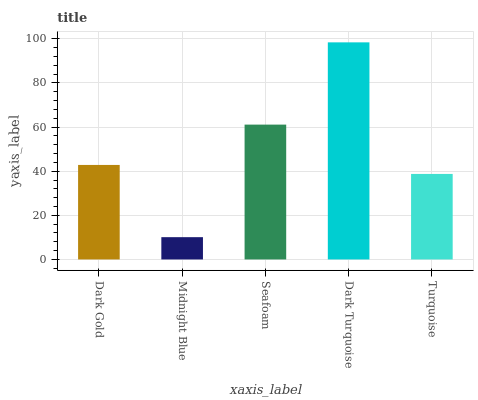Is Midnight Blue the minimum?
Answer yes or no. Yes. Is Dark Turquoise the maximum?
Answer yes or no. Yes. Is Seafoam the minimum?
Answer yes or no. No. Is Seafoam the maximum?
Answer yes or no. No. Is Seafoam greater than Midnight Blue?
Answer yes or no. Yes. Is Midnight Blue less than Seafoam?
Answer yes or no. Yes. Is Midnight Blue greater than Seafoam?
Answer yes or no. No. Is Seafoam less than Midnight Blue?
Answer yes or no. No. Is Dark Gold the high median?
Answer yes or no. Yes. Is Dark Gold the low median?
Answer yes or no. Yes. Is Turquoise the high median?
Answer yes or no. No. Is Midnight Blue the low median?
Answer yes or no. No. 